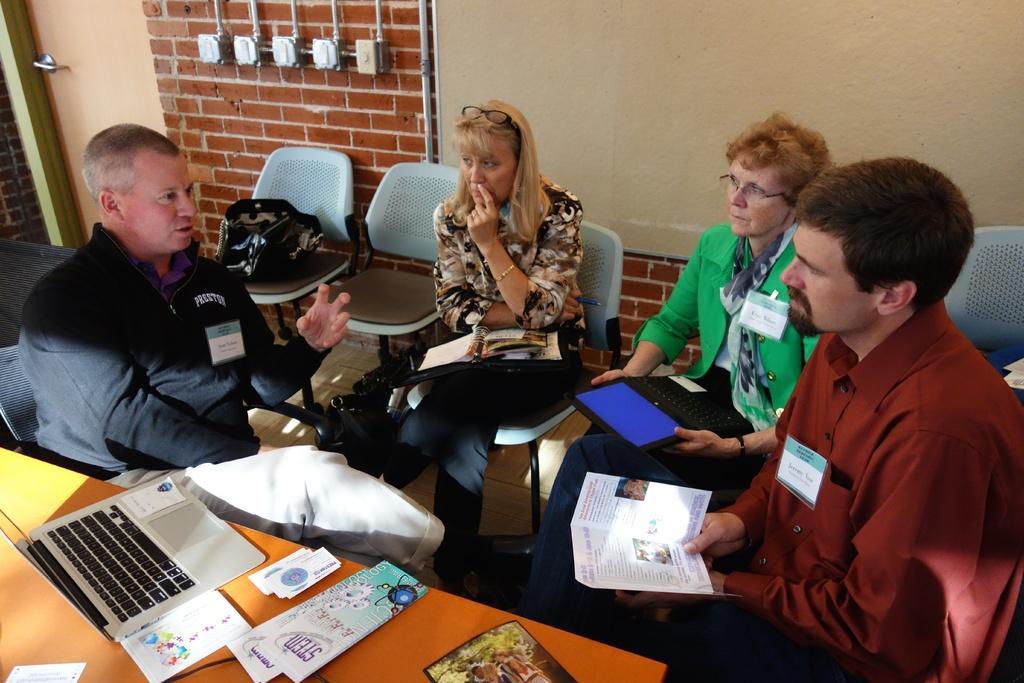Please provide a concise description of this image. In this picture there is a table at the bottom side of the image, on which there is a laptop and pamphlets and there are people those who are sitting in the center of the image, on chairs, by holding books and a tablet, there are chairs in the image and there is a door in the background area of the image. 